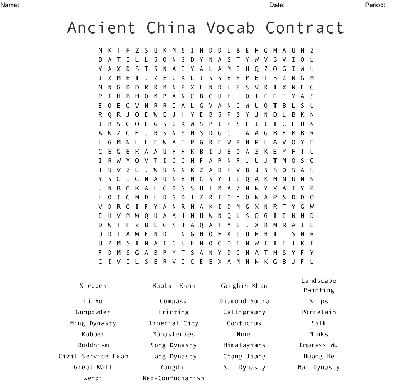What kind of words can be expected to be found in this word search? This word search includes words related to key aspects of Ancient China, encompassing historical periods, important philosophical concepts, names of dynasties like 'Tang' and 'Qin,' and terms related to traditional Chinese practices and government. 